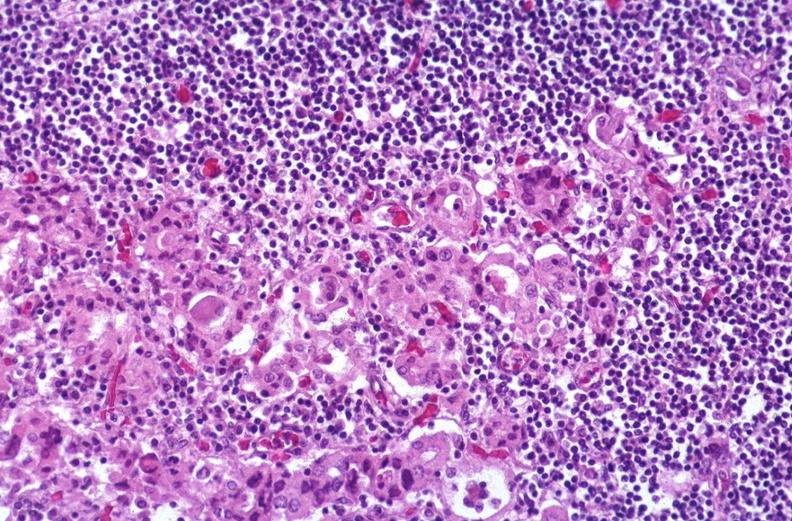s muscle atrophy present?
Answer the question using a single word or phrase. No 